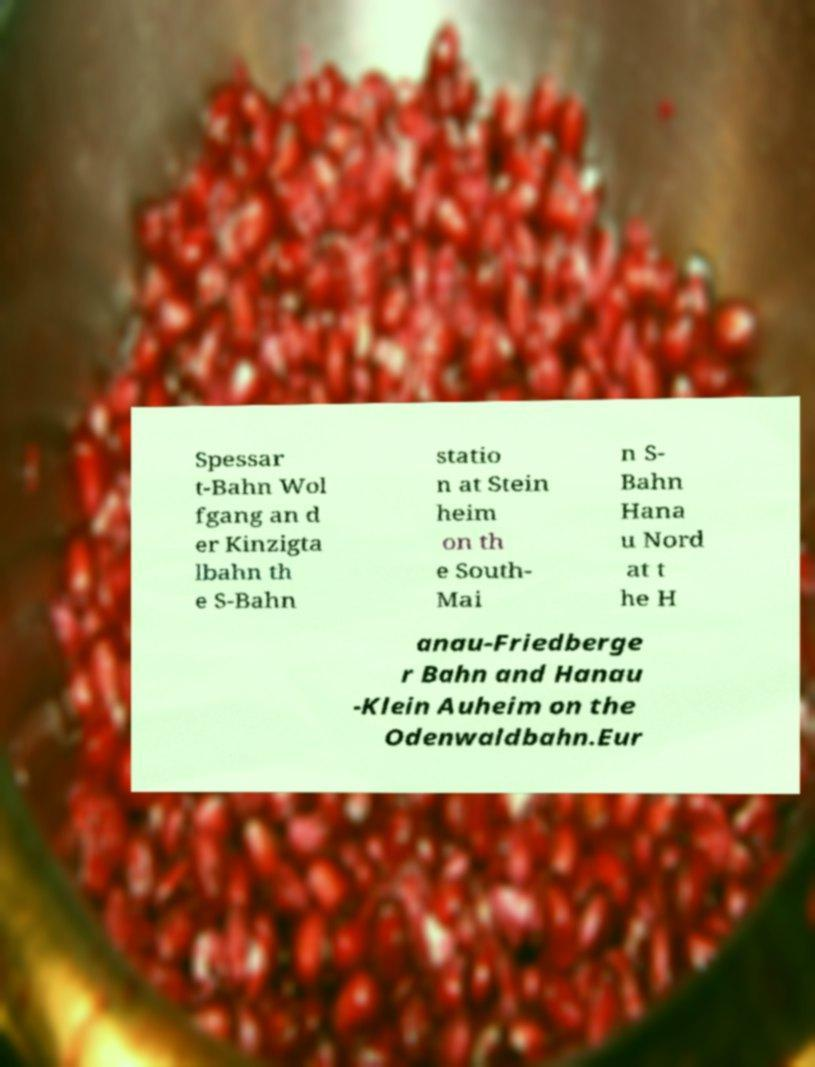Please read and relay the text visible in this image. What does it say? Spessar t-Bahn Wol fgang an d er Kinzigta lbahn th e S-Bahn statio n at Stein heim on th e South- Mai n S- Bahn Hana u Nord at t he H anau-Friedberge r Bahn and Hanau -Klein Auheim on the Odenwaldbahn.Eur 